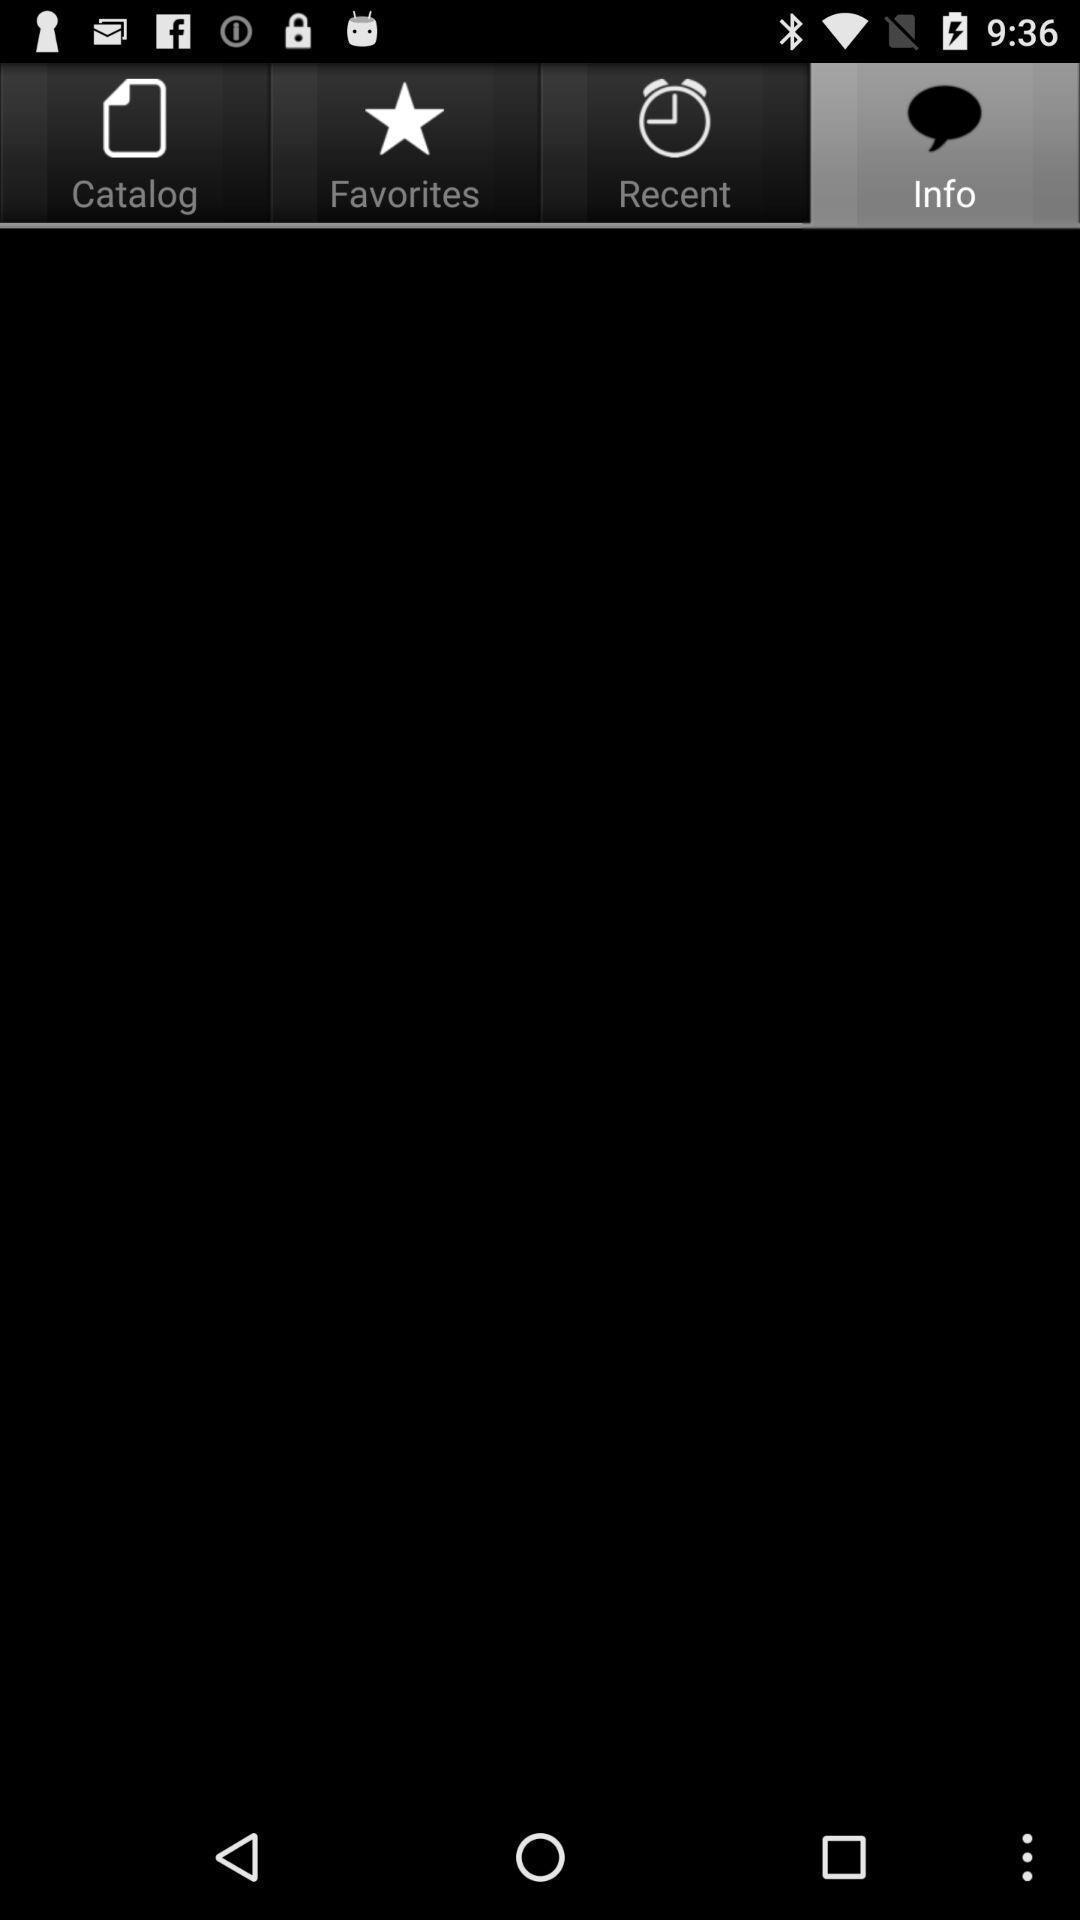Give me a narrative description of this picture. Screen showing different kinds of icons. 